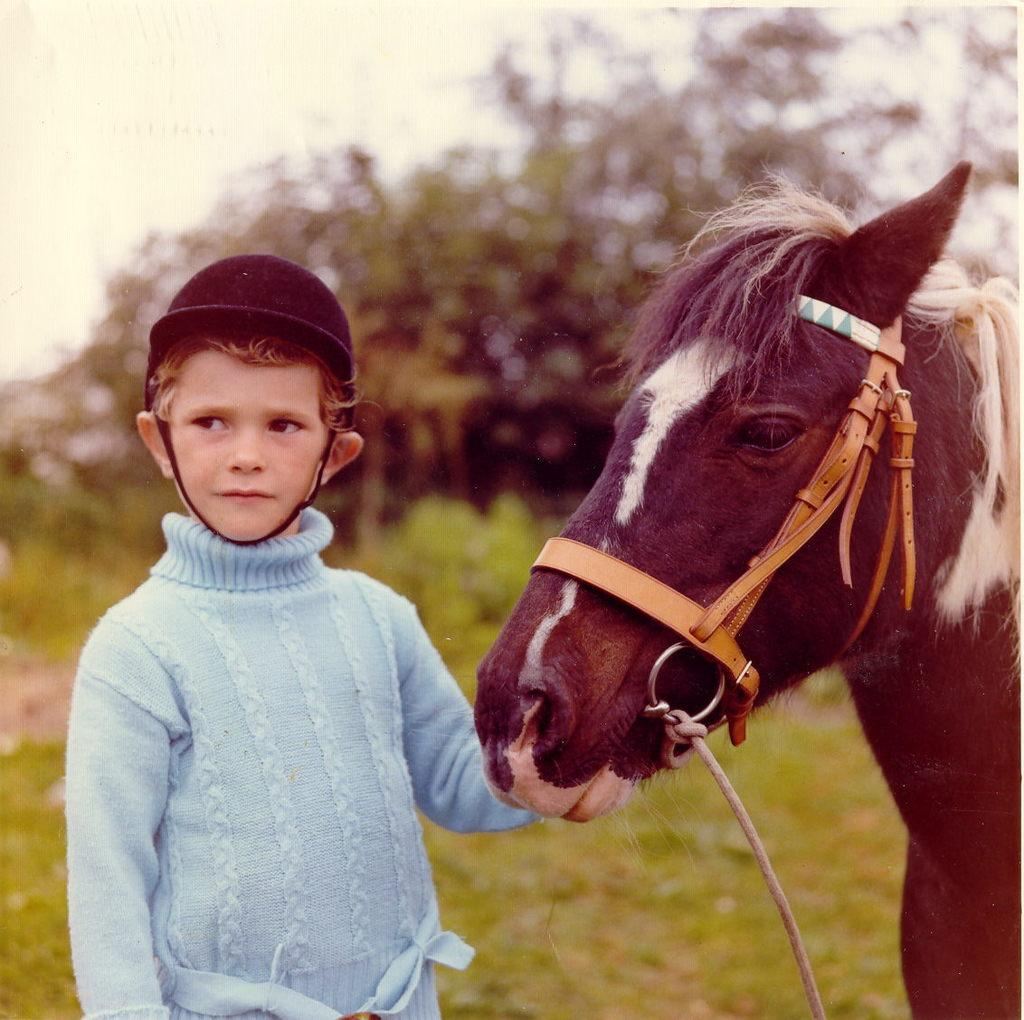What animal is on the right side of the image? There is a horse on the right side of the image. What is the boy doing on the left side of the image? The boy is standing on the left side of the image and has his hand on the horse. What can be seen in the background of the image? There are trees in the background of the image. How many cherries can be seen on the horse's back in the image? There are no cherries present in the image, and therefore none can be seen on the horse's back. What type of joke is the boy telling the horse in the image? There is no indication in the image that the boy is telling a joke to the horse. 